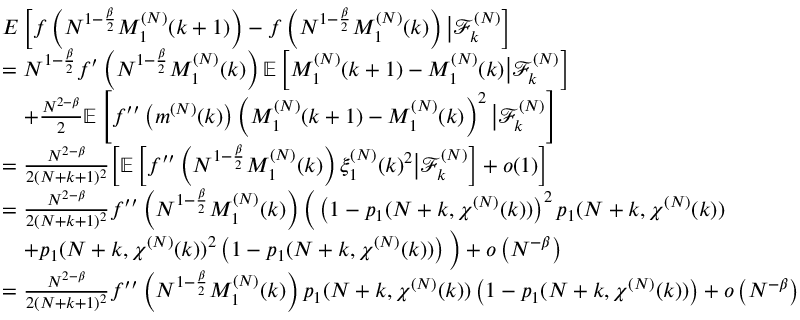<formula> <loc_0><loc_0><loc_500><loc_500>\begin{array} { r l } & { E \left [ f \left ( N ^ { 1 - \frac { \beta } { 2 } } M _ { 1 } ^ { ( N ) } ( k + 1 ) \right ) - f \left ( N ^ { 1 - \frac { \beta } { 2 } } M _ { 1 } ^ { ( N ) } ( k ) \right ) \left | \mathcal { F } _ { k } ^ { ( N ) } \right ] } \\ & { = N ^ { 1 - \frac { \beta } { 2 } } f ^ { \prime } \left ( N ^ { 1 - \frac { \beta } { 2 } } M _ { 1 } ^ { ( N ) } ( k ) \right ) \mathbb { E } \left [ M _ { 1 } ^ { ( N ) } ( k + 1 ) - M _ { 1 } ^ { ( N ) } ( k ) \right | \mathcal { F } _ { k } ^ { ( N ) } \right ] } \\ & { \quad + \frac { N ^ { 2 - \beta } } { 2 } \mathbb { E } \left [ f ^ { \prime \prime } \left ( m ^ { ( N ) } ( k ) \right ) \left ( M _ { 1 } ^ { ( N ) } ( k + 1 ) - M _ { 1 } ^ { ( N ) } ( k ) \right ) ^ { 2 } \left | \mathcal { F } _ { k } ^ { ( N ) } \right ] } \\ & { = \frac { N ^ { 2 - \beta } } { 2 ( N + k + 1 ) ^ { 2 } } \left [ \mathbb { E } \left [ f ^ { \prime \prime } \left ( N ^ { 1 - \frac { \beta } { 2 } } M _ { 1 } ^ { ( N ) } ( k ) \right ) \xi _ { 1 } ^ { ( N ) } ( k ) ^ { 2 } \right | \mathcal { F } _ { k } ^ { ( N ) } \right ] + o ( 1 ) \right ] } \\ & { = \frac { N ^ { 2 - \beta } } { 2 ( N + k + 1 ) ^ { 2 } } f ^ { \prime \prime } \left ( N ^ { 1 - \frac { \beta } { 2 } } M _ { 1 } ^ { ( N ) } ( k ) \right ) \left ( \left ( 1 - p _ { 1 } ( N + k , \chi ^ { ( N ) } ( k ) ) \right ) ^ { 2 } p _ { 1 } ( N + k , \chi ^ { ( N ) } ( k ) ) } \\ & { \quad + p _ { 1 } ( N + k , \chi ^ { ( N ) } ( k ) ) ^ { 2 } \left ( 1 - p _ { 1 } ( N + k , \chi ^ { ( N ) } ( k ) ) \right ) \right ) + o \left ( N ^ { - \beta } \right ) } \\ & { = \frac { N ^ { 2 - \beta } } { 2 ( N + k + 1 ) ^ { 2 } } f ^ { \prime \prime } \left ( N ^ { 1 - \frac { \beta } { 2 } } M _ { 1 } ^ { ( N ) } ( k ) \right ) p _ { 1 } ( N + k , \chi ^ { ( N ) } ( k ) ) \left ( 1 - p _ { 1 } ( N + k , \chi ^ { ( N ) } ( k ) ) \right ) + o \left ( N ^ { - \beta } \right ) } \end{array}</formula> 